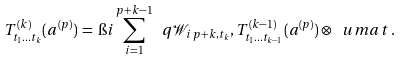Convert formula to latex. <formula><loc_0><loc_0><loc_500><loc_500>T ^ { ( k ) } _ { t _ { 1 } \dots t _ { k } } ( a ^ { ( p ) } ) \, = \, \i i \sum _ { i = 1 } ^ { p + k - 1 } \ q { \mathcal { W } _ { i \, p + k , t _ { k } } , T ^ { ( k - 1 ) } _ { t _ { 1 } \dots t _ { k - 1 } } ( a ^ { ( p ) } ) \otimes \ u m a t } \, .</formula> 